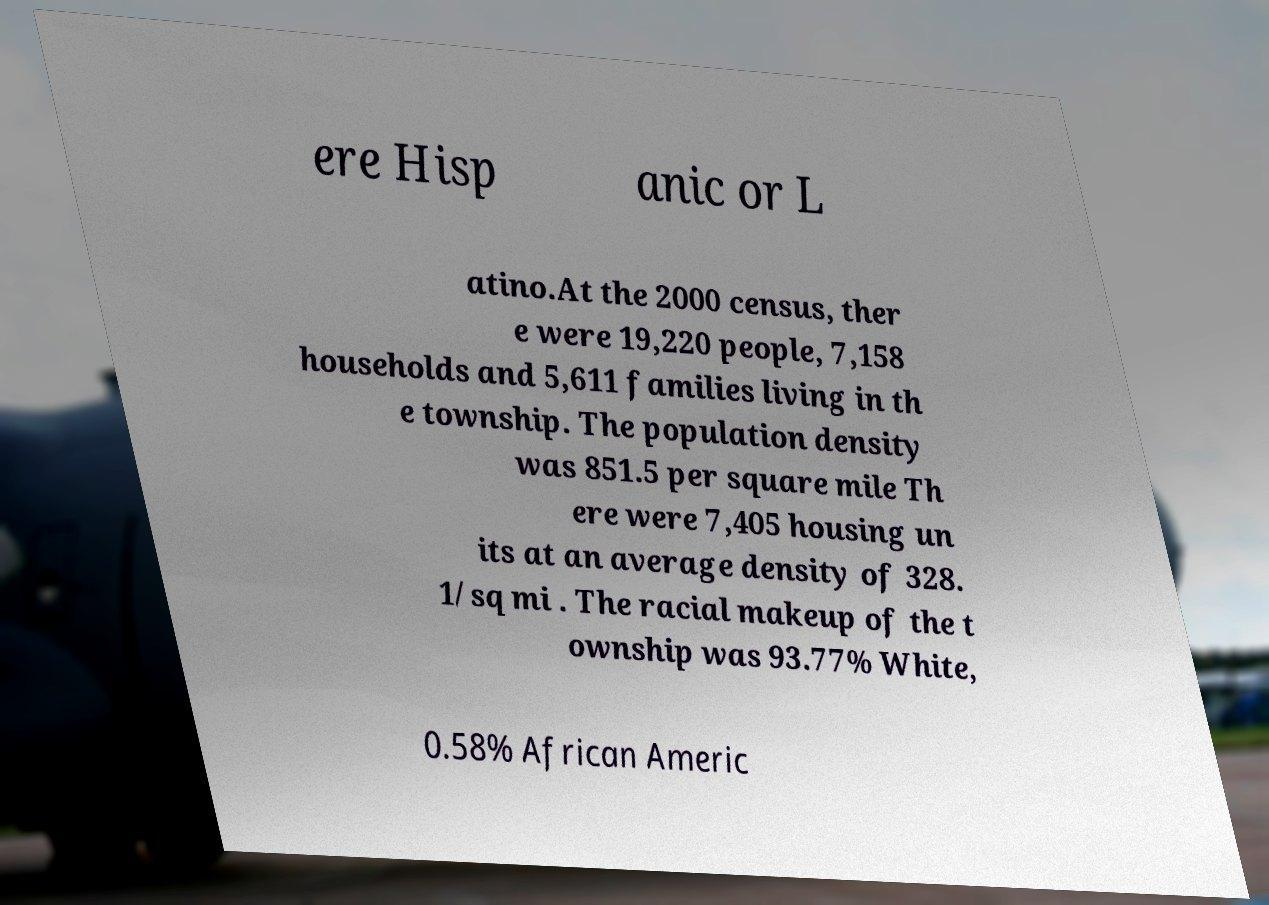Please identify and transcribe the text found in this image. ere Hisp anic or L atino.At the 2000 census, ther e were 19,220 people, 7,158 households and 5,611 families living in th e township. The population density was 851.5 per square mile Th ere were 7,405 housing un its at an average density of 328. 1/sq mi . The racial makeup of the t ownship was 93.77% White, 0.58% African Americ 